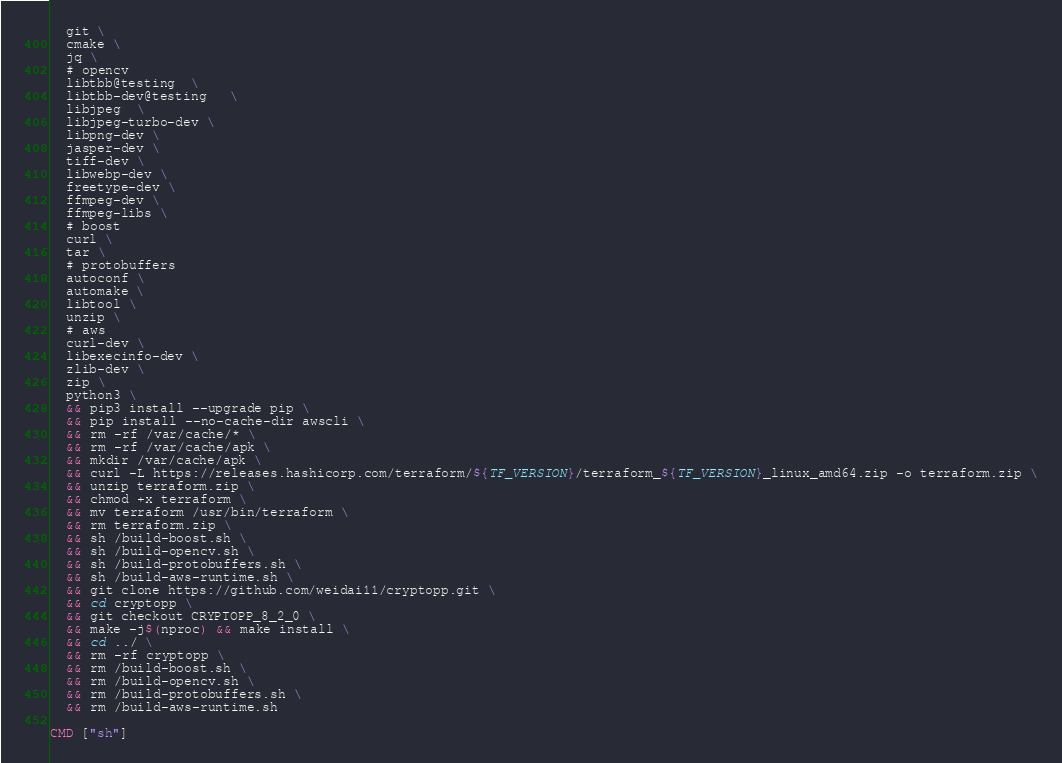Convert code to text. <code><loc_0><loc_0><loc_500><loc_500><_Dockerfile_>  git \
  cmake \
  jq \
  # opencv
  libtbb@testing  \
  libtbb-dev@testing   \
  libjpeg  \
  libjpeg-turbo-dev \
  libpng-dev \
  jasper-dev \
  tiff-dev \
  libwebp-dev \
  freetype-dev \
  ffmpeg-dev \
  ffmpeg-libs \
  # boost
  curl \
  tar \
  # protobuffers
  autoconf \
  automake \
  libtool \
  unzip \
  # aws
  curl-dev \
  libexecinfo-dev \
  zlib-dev \
  zip \
  python3 \
  && pip3 install --upgrade pip \
  && pip install --no-cache-dir awscli \
  && rm -rf /var/cache/* \
  && rm -rf /var/cache/apk \
  && mkdir /var/cache/apk \
  && curl -L https://releases.hashicorp.com/terraform/${TF_VERSION}/terraform_${TF_VERSION}_linux_amd64.zip -o terraform.zip \
  && unzip terraform.zip \
  && chmod +x terraform \
  && mv terraform /usr/bin/terraform \
  && rm terraform.zip \
  && sh /build-boost.sh \
  && sh /build-opencv.sh \
  && sh /build-protobuffers.sh \
  && sh /build-aws-runtime.sh \
  && git clone https://github.com/weidai11/cryptopp.git \
  && cd cryptopp \
  && git checkout CRYPTOPP_8_2_0 \
  && make -j$(nproc) && make install \
  && cd ../ \
  && rm -rf cryptopp \
  && rm /build-boost.sh \
  && rm /build-opencv.sh \
  && rm /build-protobuffers.sh \
  && rm /build-aws-runtime.sh

CMD ["sh"]</code> 